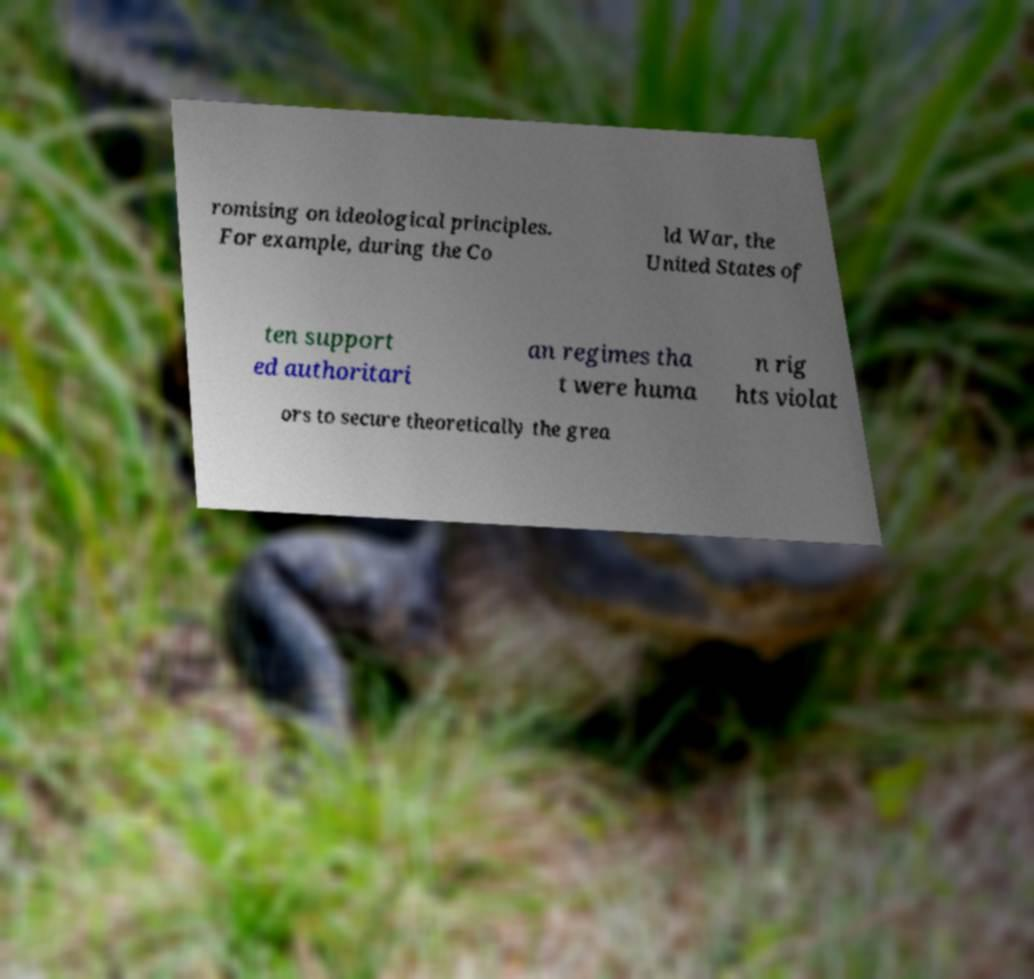Could you assist in decoding the text presented in this image and type it out clearly? romising on ideological principles. For example, during the Co ld War, the United States of ten support ed authoritari an regimes tha t were huma n rig hts violat ors to secure theoretically the grea 